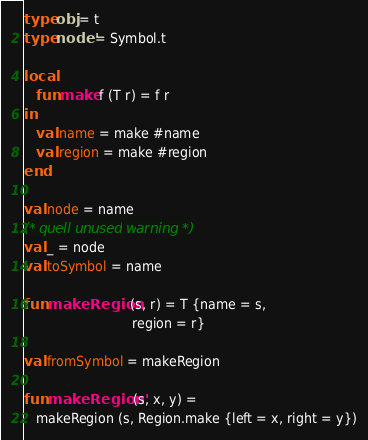<code> <loc_0><loc_0><loc_500><loc_500><_SML_>type obj = t
type node' = Symbol.t

local
   fun make f (T r) = f r
in
   val name = make #name
   val region = make #region
end

val node = name
(* quell unused warning *)
val _ = node
val toSymbol = name

fun makeRegion (s, r) = T {name = s,
                           region = r}

val fromSymbol = makeRegion

fun makeRegion' (s, x, y) =
   makeRegion (s, Region.make {left = x, right = y})</code> 